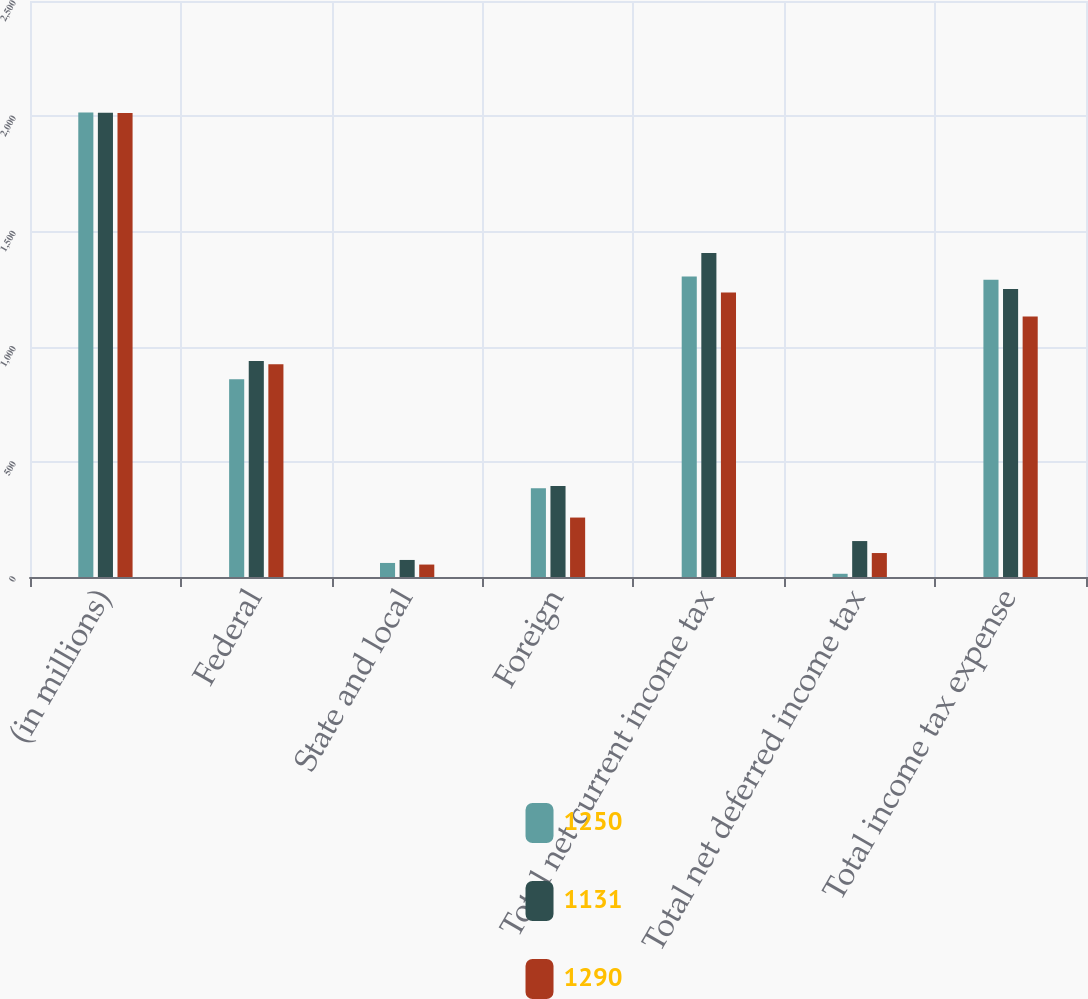Convert chart. <chart><loc_0><loc_0><loc_500><loc_500><stacked_bar_chart><ecel><fcel>(in millions)<fcel>Federal<fcel>State and local<fcel>Foreign<fcel>Total net current income tax<fcel>Total net deferred income tax<fcel>Total income tax expense<nl><fcel>1250<fcel>2016<fcel>858<fcel>61<fcel>385<fcel>1304<fcel>14<fcel>1290<nl><fcel>1131<fcel>2015<fcel>937<fcel>74<fcel>395<fcel>1406<fcel>156<fcel>1250<nl><fcel>1290<fcel>2014<fcel>923<fcel>54<fcel>258<fcel>1235<fcel>104<fcel>1131<nl></chart> 